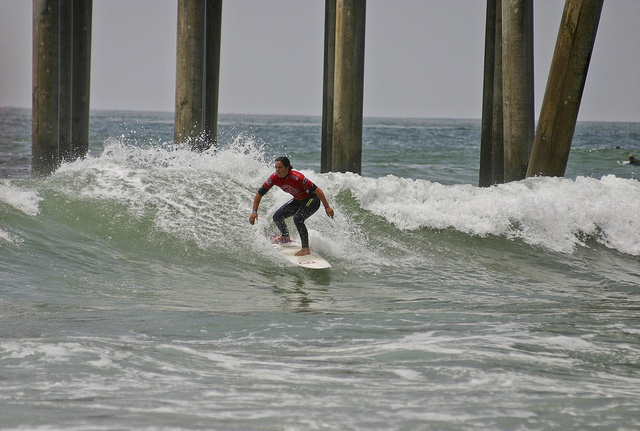Describe the objects in this image and their specific colors. I can see people in gray, black, and maroon tones, surfboard in gray, darkgray, and lightgray tones, and surfboard in gray, darkgray, and teal tones in this image. 